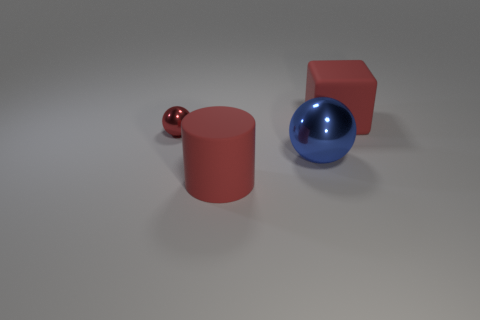Add 3 large blocks. How many objects exist? 7 Subtract all cylinders. How many objects are left? 3 Subtract 0 gray cylinders. How many objects are left? 4 Subtract all red balls. Subtract all balls. How many objects are left? 1 Add 3 small objects. How many small objects are left? 4 Add 4 big rubber cubes. How many big rubber cubes exist? 5 